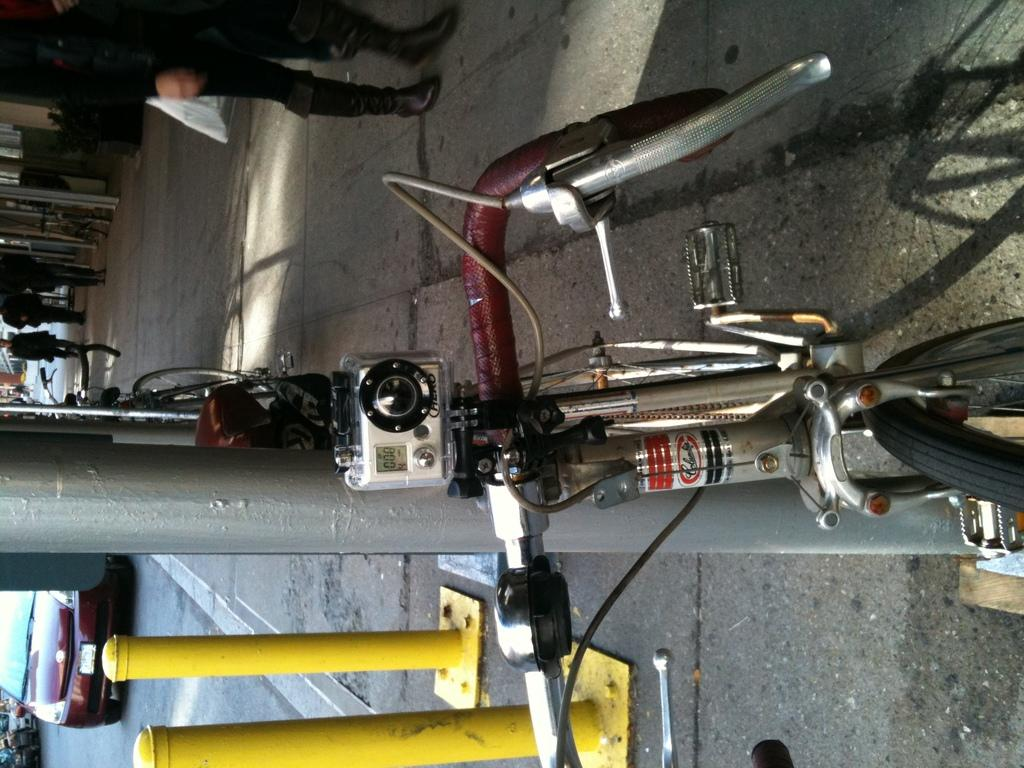What type of transportation can be seen on the road in the image? There are vehicles on the road in the image. What mode of transportation is visible besides the vehicles? There is a bicycle visible in the image. What are the people in the image doing? There are people walking on a path in the image. What type of game is being played on the road in the image? There is no game being played on the road in the image. How are the people sorting the items on the path in the image? There is no sorting activity depicted in the image; people are simply walking on the path. 